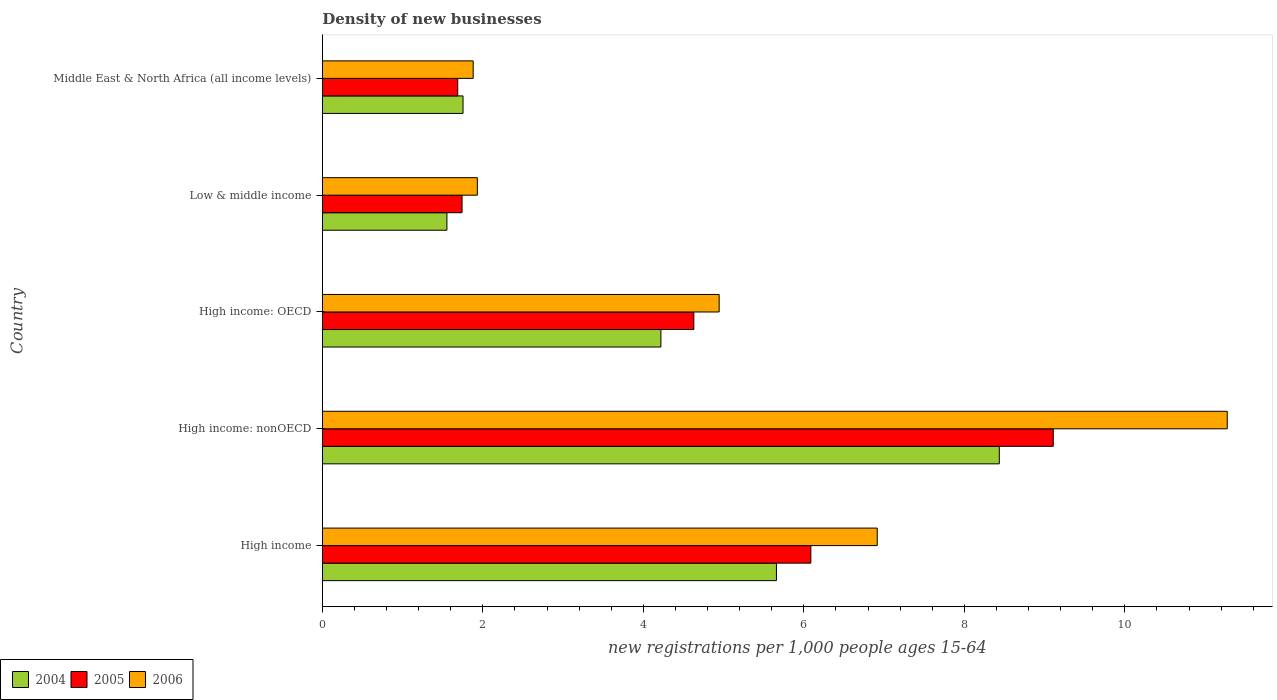How many different coloured bars are there?
Give a very brief answer. 3. Are the number of bars per tick equal to the number of legend labels?
Give a very brief answer. Yes. Are the number of bars on each tick of the Y-axis equal?
Provide a short and direct response. Yes. How many bars are there on the 5th tick from the top?
Your response must be concise. 3. What is the label of the 4th group of bars from the top?
Your answer should be compact. High income: nonOECD. In how many cases, is the number of bars for a given country not equal to the number of legend labels?
Your answer should be very brief. 0. What is the number of new registrations in 2005 in Low & middle income?
Offer a very short reply. 1.74. Across all countries, what is the maximum number of new registrations in 2006?
Offer a very short reply. 11.28. Across all countries, what is the minimum number of new registrations in 2005?
Make the answer very short. 1.69. In which country was the number of new registrations in 2005 maximum?
Your answer should be compact. High income: nonOECD. In which country was the number of new registrations in 2004 minimum?
Give a very brief answer. Low & middle income. What is the total number of new registrations in 2004 in the graph?
Give a very brief answer. 21.62. What is the difference between the number of new registrations in 2005 in High income: OECD and that in Middle East & North Africa (all income levels)?
Your answer should be very brief. 2.94. What is the difference between the number of new registrations in 2004 in High income and the number of new registrations in 2005 in Middle East & North Africa (all income levels)?
Ensure brevity in your answer.  3.97. What is the average number of new registrations in 2004 per country?
Provide a succinct answer. 4.32. What is the difference between the number of new registrations in 2006 and number of new registrations in 2004 in High income?
Your answer should be very brief. 1.26. In how many countries, is the number of new registrations in 2006 greater than 0.4 ?
Provide a short and direct response. 5. What is the ratio of the number of new registrations in 2004 in High income: OECD to that in High income: nonOECD?
Give a very brief answer. 0.5. Is the number of new registrations in 2004 in High income: OECD less than that in Middle East & North Africa (all income levels)?
Offer a very short reply. No. Is the difference between the number of new registrations in 2006 in High income and Middle East & North Africa (all income levels) greater than the difference between the number of new registrations in 2004 in High income and Middle East & North Africa (all income levels)?
Provide a short and direct response. Yes. What is the difference between the highest and the second highest number of new registrations in 2005?
Ensure brevity in your answer.  3.02. What is the difference between the highest and the lowest number of new registrations in 2004?
Give a very brief answer. 6.88. Are all the bars in the graph horizontal?
Provide a succinct answer. Yes. How many countries are there in the graph?
Provide a succinct answer. 5. Where does the legend appear in the graph?
Your response must be concise. Bottom left. What is the title of the graph?
Keep it short and to the point. Density of new businesses. What is the label or title of the X-axis?
Keep it short and to the point. New registrations per 1,0 people ages 15-64. What is the new registrations per 1,000 people ages 15-64 in 2004 in High income?
Your response must be concise. 5.66. What is the new registrations per 1,000 people ages 15-64 of 2005 in High income?
Make the answer very short. 6.09. What is the new registrations per 1,000 people ages 15-64 in 2006 in High income?
Offer a very short reply. 6.91. What is the new registrations per 1,000 people ages 15-64 in 2004 in High income: nonOECD?
Provide a short and direct response. 8.44. What is the new registrations per 1,000 people ages 15-64 in 2005 in High income: nonOECD?
Your answer should be compact. 9.11. What is the new registrations per 1,000 people ages 15-64 in 2006 in High income: nonOECD?
Your answer should be very brief. 11.28. What is the new registrations per 1,000 people ages 15-64 in 2004 in High income: OECD?
Keep it short and to the point. 4.22. What is the new registrations per 1,000 people ages 15-64 of 2005 in High income: OECD?
Offer a very short reply. 4.63. What is the new registrations per 1,000 people ages 15-64 of 2006 in High income: OECD?
Make the answer very short. 4.94. What is the new registrations per 1,000 people ages 15-64 in 2004 in Low & middle income?
Ensure brevity in your answer.  1.55. What is the new registrations per 1,000 people ages 15-64 in 2005 in Low & middle income?
Your response must be concise. 1.74. What is the new registrations per 1,000 people ages 15-64 of 2006 in Low & middle income?
Keep it short and to the point. 1.93. What is the new registrations per 1,000 people ages 15-64 of 2004 in Middle East & North Africa (all income levels)?
Ensure brevity in your answer.  1.75. What is the new registrations per 1,000 people ages 15-64 in 2005 in Middle East & North Africa (all income levels)?
Offer a very short reply. 1.69. What is the new registrations per 1,000 people ages 15-64 in 2006 in Middle East & North Africa (all income levels)?
Your response must be concise. 1.88. Across all countries, what is the maximum new registrations per 1,000 people ages 15-64 in 2004?
Offer a terse response. 8.44. Across all countries, what is the maximum new registrations per 1,000 people ages 15-64 in 2005?
Make the answer very short. 9.11. Across all countries, what is the maximum new registrations per 1,000 people ages 15-64 of 2006?
Keep it short and to the point. 11.28. Across all countries, what is the minimum new registrations per 1,000 people ages 15-64 of 2004?
Your answer should be very brief. 1.55. Across all countries, what is the minimum new registrations per 1,000 people ages 15-64 of 2005?
Offer a terse response. 1.69. Across all countries, what is the minimum new registrations per 1,000 people ages 15-64 of 2006?
Make the answer very short. 1.88. What is the total new registrations per 1,000 people ages 15-64 of 2004 in the graph?
Provide a short and direct response. 21.62. What is the total new registrations per 1,000 people ages 15-64 in 2005 in the graph?
Provide a short and direct response. 23.25. What is the total new registrations per 1,000 people ages 15-64 in 2006 in the graph?
Make the answer very short. 26.95. What is the difference between the new registrations per 1,000 people ages 15-64 of 2004 in High income and that in High income: nonOECD?
Your response must be concise. -2.78. What is the difference between the new registrations per 1,000 people ages 15-64 of 2005 in High income and that in High income: nonOECD?
Provide a short and direct response. -3.02. What is the difference between the new registrations per 1,000 people ages 15-64 of 2006 in High income and that in High income: nonOECD?
Provide a succinct answer. -4.36. What is the difference between the new registrations per 1,000 people ages 15-64 of 2004 in High income and that in High income: OECD?
Offer a terse response. 1.44. What is the difference between the new registrations per 1,000 people ages 15-64 of 2005 in High income and that in High income: OECD?
Keep it short and to the point. 1.46. What is the difference between the new registrations per 1,000 people ages 15-64 of 2006 in High income and that in High income: OECD?
Ensure brevity in your answer.  1.97. What is the difference between the new registrations per 1,000 people ages 15-64 of 2004 in High income and that in Low & middle income?
Keep it short and to the point. 4.11. What is the difference between the new registrations per 1,000 people ages 15-64 in 2005 in High income and that in Low & middle income?
Your answer should be very brief. 4.35. What is the difference between the new registrations per 1,000 people ages 15-64 of 2006 in High income and that in Low & middle income?
Make the answer very short. 4.98. What is the difference between the new registrations per 1,000 people ages 15-64 of 2004 in High income and that in Middle East & North Africa (all income levels)?
Your answer should be very brief. 3.91. What is the difference between the new registrations per 1,000 people ages 15-64 of 2005 in High income and that in Middle East & North Africa (all income levels)?
Ensure brevity in your answer.  4.4. What is the difference between the new registrations per 1,000 people ages 15-64 of 2006 in High income and that in Middle East & North Africa (all income levels)?
Ensure brevity in your answer.  5.04. What is the difference between the new registrations per 1,000 people ages 15-64 of 2004 in High income: nonOECD and that in High income: OECD?
Provide a succinct answer. 4.22. What is the difference between the new registrations per 1,000 people ages 15-64 of 2005 in High income: nonOECD and that in High income: OECD?
Your response must be concise. 4.48. What is the difference between the new registrations per 1,000 people ages 15-64 of 2006 in High income: nonOECD and that in High income: OECD?
Provide a short and direct response. 6.33. What is the difference between the new registrations per 1,000 people ages 15-64 of 2004 in High income: nonOECD and that in Low & middle income?
Keep it short and to the point. 6.88. What is the difference between the new registrations per 1,000 people ages 15-64 in 2005 in High income: nonOECD and that in Low & middle income?
Provide a short and direct response. 7.37. What is the difference between the new registrations per 1,000 people ages 15-64 of 2006 in High income: nonOECD and that in Low & middle income?
Make the answer very short. 9.34. What is the difference between the new registrations per 1,000 people ages 15-64 in 2004 in High income: nonOECD and that in Middle East & North Africa (all income levels)?
Provide a short and direct response. 6.68. What is the difference between the new registrations per 1,000 people ages 15-64 in 2005 in High income: nonOECD and that in Middle East & North Africa (all income levels)?
Your answer should be compact. 7.42. What is the difference between the new registrations per 1,000 people ages 15-64 of 2006 in High income: nonOECD and that in Middle East & North Africa (all income levels)?
Keep it short and to the point. 9.4. What is the difference between the new registrations per 1,000 people ages 15-64 of 2004 in High income: OECD and that in Low & middle income?
Ensure brevity in your answer.  2.67. What is the difference between the new registrations per 1,000 people ages 15-64 of 2005 in High income: OECD and that in Low & middle income?
Ensure brevity in your answer.  2.89. What is the difference between the new registrations per 1,000 people ages 15-64 in 2006 in High income: OECD and that in Low & middle income?
Provide a succinct answer. 3.01. What is the difference between the new registrations per 1,000 people ages 15-64 of 2004 in High income: OECD and that in Middle East & North Africa (all income levels)?
Keep it short and to the point. 2.47. What is the difference between the new registrations per 1,000 people ages 15-64 in 2005 in High income: OECD and that in Middle East & North Africa (all income levels)?
Offer a very short reply. 2.94. What is the difference between the new registrations per 1,000 people ages 15-64 in 2006 in High income: OECD and that in Middle East & North Africa (all income levels)?
Your answer should be very brief. 3.07. What is the difference between the new registrations per 1,000 people ages 15-64 in 2004 in Low & middle income and that in Middle East & North Africa (all income levels)?
Ensure brevity in your answer.  -0.2. What is the difference between the new registrations per 1,000 people ages 15-64 of 2005 in Low & middle income and that in Middle East & North Africa (all income levels)?
Make the answer very short. 0.05. What is the difference between the new registrations per 1,000 people ages 15-64 of 2006 in Low & middle income and that in Middle East & North Africa (all income levels)?
Make the answer very short. 0.05. What is the difference between the new registrations per 1,000 people ages 15-64 of 2004 in High income and the new registrations per 1,000 people ages 15-64 of 2005 in High income: nonOECD?
Offer a terse response. -3.45. What is the difference between the new registrations per 1,000 people ages 15-64 of 2004 in High income and the new registrations per 1,000 people ages 15-64 of 2006 in High income: nonOECD?
Keep it short and to the point. -5.62. What is the difference between the new registrations per 1,000 people ages 15-64 of 2005 in High income and the new registrations per 1,000 people ages 15-64 of 2006 in High income: nonOECD?
Ensure brevity in your answer.  -5.19. What is the difference between the new registrations per 1,000 people ages 15-64 in 2004 in High income and the new registrations per 1,000 people ages 15-64 in 2005 in High income: OECD?
Keep it short and to the point. 1.03. What is the difference between the new registrations per 1,000 people ages 15-64 of 2004 in High income and the new registrations per 1,000 people ages 15-64 of 2006 in High income: OECD?
Your answer should be compact. 0.71. What is the difference between the new registrations per 1,000 people ages 15-64 in 2005 in High income and the new registrations per 1,000 people ages 15-64 in 2006 in High income: OECD?
Your answer should be compact. 1.14. What is the difference between the new registrations per 1,000 people ages 15-64 of 2004 in High income and the new registrations per 1,000 people ages 15-64 of 2005 in Low & middle income?
Offer a terse response. 3.92. What is the difference between the new registrations per 1,000 people ages 15-64 in 2004 in High income and the new registrations per 1,000 people ages 15-64 in 2006 in Low & middle income?
Give a very brief answer. 3.73. What is the difference between the new registrations per 1,000 people ages 15-64 in 2005 in High income and the new registrations per 1,000 people ages 15-64 in 2006 in Low & middle income?
Provide a short and direct response. 4.16. What is the difference between the new registrations per 1,000 people ages 15-64 in 2004 in High income and the new registrations per 1,000 people ages 15-64 in 2005 in Middle East & North Africa (all income levels)?
Give a very brief answer. 3.97. What is the difference between the new registrations per 1,000 people ages 15-64 in 2004 in High income and the new registrations per 1,000 people ages 15-64 in 2006 in Middle East & North Africa (all income levels)?
Offer a terse response. 3.78. What is the difference between the new registrations per 1,000 people ages 15-64 of 2005 in High income and the new registrations per 1,000 people ages 15-64 of 2006 in Middle East & North Africa (all income levels)?
Offer a terse response. 4.21. What is the difference between the new registrations per 1,000 people ages 15-64 of 2004 in High income: nonOECD and the new registrations per 1,000 people ages 15-64 of 2005 in High income: OECD?
Make the answer very short. 3.81. What is the difference between the new registrations per 1,000 people ages 15-64 of 2004 in High income: nonOECD and the new registrations per 1,000 people ages 15-64 of 2006 in High income: OECD?
Provide a succinct answer. 3.49. What is the difference between the new registrations per 1,000 people ages 15-64 in 2005 in High income: nonOECD and the new registrations per 1,000 people ages 15-64 in 2006 in High income: OECD?
Keep it short and to the point. 4.16. What is the difference between the new registrations per 1,000 people ages 15-64 in 2004 in High income: nonOECD and the new registrations per 1,000 people ages 15-64 in 2005 in Low & middle income?
Ensure brevity in your answer.  6.69. What is the difference between the new registrations per 1,000 people ages 15-64 in 2004 in High income: nonOECD and the new registrations per 1,000 people ages 15-64 in 2006 in Low & middle income?
Your response must be concise. 6.5. What is the difference between the new registrations per 1,000 people ages 15-64 in 2005 in High income: nonOECD and the new registrations per 1,000 people ages 15-64 in 2006 in Low & middle income?
Offer a terse response. 7.18. What is the difference between the new registrations per 1,000 people ages 15-64 of 2004 in High income: nonOECD and the new registrations per 1,000 people ages 15-64 of 2005 in Middle East & North Africa (all income levels)?
Your answer should be compact. 6.75. What is the difference between the new registrations per 1,000 people ages 15-64 of 2004 in High income: nonOECD and the new registrations per 1,000 people ages 15-64 of 2006 in Middle East & North Africa (all income levels)?
Offer a terse response. 6.56. What is the difference between the new registrations per 1,000 people ages 15-64 of 2005 in High income: nonOECD and the new registrations per 1,000 people ages 15-64 of 2006 in Middle East & North Africa (all income levels)?
Your response must be concise. 7.23. What is the difference between the new registrations per 1,000 people ages 15-64 in 2004 in High income: OECD and the new registrations per 1,000 people ages 15-64 in 2005 in Low & middle income?
Offer a terse response. 2.48. What is the difference between the new registrations per 1,000 people ages 15-64 in 2004 in High income: OECD and the new registrations per 1,000 people ages 15-64 in 2006 in Low & middle income?
Provide a succinct answer. 2.29. What is the difference between the new registrations per 1,000 people ages 15-64 of 2005 in High income: OECD and the new registrations per 1,000 people ages 15-64 of 2006 in Low & middle income?
Provide a succinct answer. 2.7. What is the difference between the new registrations per 1,000 people ages 15-64 in 2004 in High income: OECD and the new registrations per 1,000 people ages 15-64 in 2005 in Middle East & North Africa (all income levels)?
Give a very brief answer. 2.53. What is the difference between the new registrations per 1,000 people ages 15-64 of 2004 in High income: OECD and the new registrations per 1,000 people ages 15-64 of 2006 in Middle East & North Africa (all income levels)?
Make the answer very short. 2.34. What is the difference between the new registrations per 1,000 people ages 15-64 of 2005 in High income: OECD and the new registrations per 1,000 people ages 15-64 of 2006 in Middle East & North Africa (all income levels)?
Your answer should be compact. 2.75. What is the difference between the new registrations per 1,000 people ages 15-64 of 2004 in Low & middle income and the new registrations per 1,000 people ages 15-64 of 2005 in Middle East & North Africa (all income levels)?
Provide a succinct answer. -0.13. What is the difference between the new registrations per 1,000 people ages 15-64 in 2004 in Low & middle income and the new registrations per 1,000 people ages 15-64 in 2006 in Middle East & North Africa (all income levels)?
Give a very brief answer. -0.33. What is the difference between the new registrations per 1,000 people ages 15-64 in 2005 in Low & middle income and the new registrations per 1,000 people ages 15-64 in 2006 in Middle East & North Africa (all income levels)?
Provide a succinct answer. -0.14. What is the average new registrations per 1,000 people ages 15-64 of 2004 per country?
Keep it short and to the point. 4.32. What is the average new registrations per 1,000 people ages 15-64 of 2005 per country?
Give a very brief answer. 4.65. What is the average new registrations per 1,000 people ages 15-64 of 2006 per country?
Keep it short and to the point. 5.39. What is the difference between the new registrations per 1,000 people ages 15-64 in 2004 and new registrations per 1,000 people ages 15-64 in 2005 in High income?
Offer a terse response. -0.43. What is the difference between the new registrations per 1,000 people ages 15-64 in 2004 and new registrations per 1,000 people ages 15-64 in 2006 in High income?
Offer a terse response. -1.26. What is the difference between the new registrations per 1,000 people ages 15-64 in 2005 and new registrations per 1,000 people ages 15-64 in 2006 in High income?
Your answer should be very brief. -0.83. What is the difference between the new registrations per 1,000 people ages 15-64 of 2004 and new registrations per 1,000 people ages 15-64 of 2005 in High income: nonOECD?
Your answer should be very brief. -0.67. What is the difference between the new registrations per 1,000 people ages 15-64 in 2004 and new registrations per 1,000 people ages 15-64 in 2006 in High income: nonOECD?
Your answer should be compact. -2.84. What is the difference between the new registrations per 1,000 people ages 15-64 in 2005 and new registrations per 1,000 people ages 15-64 in 2006 in High income: nonOECD?
Your answer should be very brief. -2.17. What is the difference between the new registrations per 1,000 people ages 15-64 in 2004 and new registrations per 1,000 people ages 15-64 in 2005 in High income: OECD?
Ensure brevity in your answer.  -0.41. What is the difference between the new registrations per 1,000 people ages 15-64 of 2004 and new registrations per 1,000 people ages 15-64 of 2006 in High income: OECD?
Make the answer very short. -0.73. What is the difference between the new registrations per 1,000 people ages 15-64 in 2005 and new registrations per 1,000 people ages 15-64 in 2006 in High income: OECD?
Offer a very short reply. -0.32. What is the difference between the new registrations per 1,000 people ages 15-64 of 2004 and new registrations per 1,000 people ages 15-64 of 2005 in Low & middle income?
Your response must be concise. -0.19. What is the difference between the new registrations per 1,000 people ages 15-64 in 2004 and new registrations per 1,000 people ages 15-64 in 2006 in Low & middle income?
Offer a very short reply. -0.38. What is the difference between the new registrations per 1,000 people ages 15-64 in 2005 and new registrations per 1,000 people ages 15-64 in 2006 in Low & middle income?
Keep it short and to the point. -0.19. What is the difference between the new registrations per 1,000 people ages 15-64 in 2004 and new registrations per 1,000 people ages 15-64 in 2005 in Middle East & North Africa (all income levels)?
Ensure brevity in your answer.  0.07. What is the difference between the new registrations per 1,000 people ages 15-64 in 2004 and new registrations per 1,000 people ages 15-64 in 2006 in Middle East & North Africa (all income levels)?
Provide a succinct answer. -0.13. What is the difference between the new registrations per 1,000 people ages 15-64 of 2005 and new registrations per 1,000 people ages 15-64 of 2006 in Middle East & North Africa (all income levels)?
Give a very brief answer. -0.19. What is the ratio of the new registrations per 1,000 people ages 15-64 in 2004 in High income to that in High income: nonOECD?
Make the answer very short. 0.67. What is the ratio of the new registrations per 1,000 people ages 15-64 in 2005 in High income to that in High income: nonOECD?
Offer a very short reply. 0.67. What is the ratio of the new registrations per 1,000 people ages 15-64 of 2006 in High income to that in High income: nonOECD?
Give a very brief answer. 0.61. What is the ratio of the new registrations per 1,000 people ages 15-64 in 2004 in High income to that in High income: OECD?
Your answer should be very brief. 1.34. What is the ratio of the new registrations per 1,000 people ages 15-64 in 2005 in High income to that in High income: OECD?
Your answer should be very brief. 1.31. What is the ratio of the new registrations per 1,000 people ages 15-64 of 2006 in High income to that in High income: OECD?
Offer a terse response. 1.4. What is the ratio of the new registrations per 1,000 people ages 15-64 in 2004 in High income to that in Low & middle income?
Provide a succinct answer. 3.64. What is the ratio of the new registrations per 1,000 people ages 15-64 of 2005 in High income to that in Low & middle income?
Make the answer very short. 3.5. What is the ratio of the new registrations per 1,000 people ages 15-64 of 2006 in High income to that in Low & middle income?
Ensure brevity in your answer.  3.58. What is the ratio of the new registrations per 1,000 people ages 15-64 of 2004 in High income to that in Middle East & North Africa (all income levels)?
Make the answer very short. 3.23. What is the ratio of the new registrations per 1,000 people ages 15-64 in 2005 in High income to that in Middle East & North Africa (all income levels)?
Provide a succinct answer. 3.61. What is the ratio of the new registrations per 1,000 people ages 15-64 of 2006 in High income to that in Middle East & North Africa (all income levels)?
Offer a terse response. 3.68. What is the ratio of the new registrations per 1,000 people ages 15-64 in 2004 in High income: nonOECD to that in High income: OECD?
Your answer should be compact. 2. What is the ratio of the new registrations per 1,000 people ages 15-64 of 2005 in High income: nonOECD to that in High income: OECD?
Provide a succinct answer. 1.97. What is the ratio of the new registrations per 1,000 people ages 15-64 in 2006 in High income: nonOECD to that in High income: OECD?
Your response must be concise. 2.28. What is the ratio of the new registrations per 1,000 people ages 15-64 of 2004 in High income: nonOECD to that in Low & middle income?
Offer a very short reply. 5.43. What is the ratio of the new registrations per 1,000 people ages 15-64 of 2005 in High income: nonOECD to that in Low & middle income?
Provide a short and direct response. 5.23. What is the ratio of the new registrations per 1,000 people ages 15-64 in 2006 in High income: nonOECD to that in Low & middle income?
Give a very brief answer. 5.84. What is the ratio of the new registrations per 1,000 people ages 15-64 in 2004 in High income: nonOECD to that in Middle East & North Africa (all income levels)?
Provide a short and direct response. 4.81. What is the ratio of the new registrations per 1,000 people ages 15-64 in 2005 in High income: nonOECD to that in Middle East & North Africa (all income levels)?
Your answer should be very brief. 5.4. What is the ratio of the new registrations per 1,000 people ages 15-64 of 2006 in High income: nonOECD to that in Middle East & North Africa (all income levels)?
Your answer should be compact. 6. What is the ratio of the new registrations per 1,000 people ages 15-64 in 2004 in High income: OECD to that in Low & middle income?
Provide a short and direct response. 2.72. What is the ratio of the new registrations per 1,000 people ages 15-64 of 2005 in High income: OECD to that in Low & middle income?
Your answer should be very brief. 2.66. What is the ratio of the new registrations per 1,000 people ages 15-64 of 2006 in High income: OECD to that in Low & middle income?
Offer a very short reply. 2.56. What is the ratio of the new registrations per 1,000 people ages 15-64 in 2004 in High income: OECD to that in Middle East & North Africa (all income levels)?
Provide a succinct answer. 2.41. What is the ratio of the new registrations per 1,000 people ages 15-64 of 2005 in High income: OECD to that in Middle East & North Africa (all income levels)?
Keep it short and to the point. 2.74. What is the ratio of the new registrations per 1,000 people ages 15-64 in 2006 in High income: OECD to that in Middle East & North Africa (all income levels)?
Give a very brief answer. 2.63. What is the ratio of the new registrations per 1,000 people ages 15-64 of 2004 in Low & middle income to that in Middle East & North Africa (all income levels)?
Keep it short and to the point. 0.89. What is the ratio of the new registrations per 1,000 people ages 15-64 in 2005 in Low & middle income to that in Middle East & North Africa (all income levels)?
Offer a terse response. 1.03. What is the ratio of the new registrations per 1,000 people ages 15-64 in 2006 in Low & middle income to that in Middle East & North Africa (all income levels)?
Provide a succinct answer. 1.03. What is the difference between the highest and the second highest new registrations per 1,000 people ages 15-64 of 2004?
Provide a short and direct response. 2.78. What is the difference between the highest and the second highest new registrations per 1,000 people ages 15-64 of 2005?
Give a very brief answer. 3.02. What is the difference between the highest and the second highest new registrations per 1,000 people ages 15-64 of 2006?
Offer a terse response. 4.36. What is the difference between the highest and the lowest new registrations per 1,000 people ages 15-64 of 2004?
Offer a terse response. 6.88. What is the difference between the highest and the lowest new registrations per 1,000 people ages 15-64 in 2005?
Make the answer very short. 7.42. What is the difference between the highest and the lowest new registrations per 1,000 people ages 15-64 in 2006?
Your answer should be compact. 9.4. 